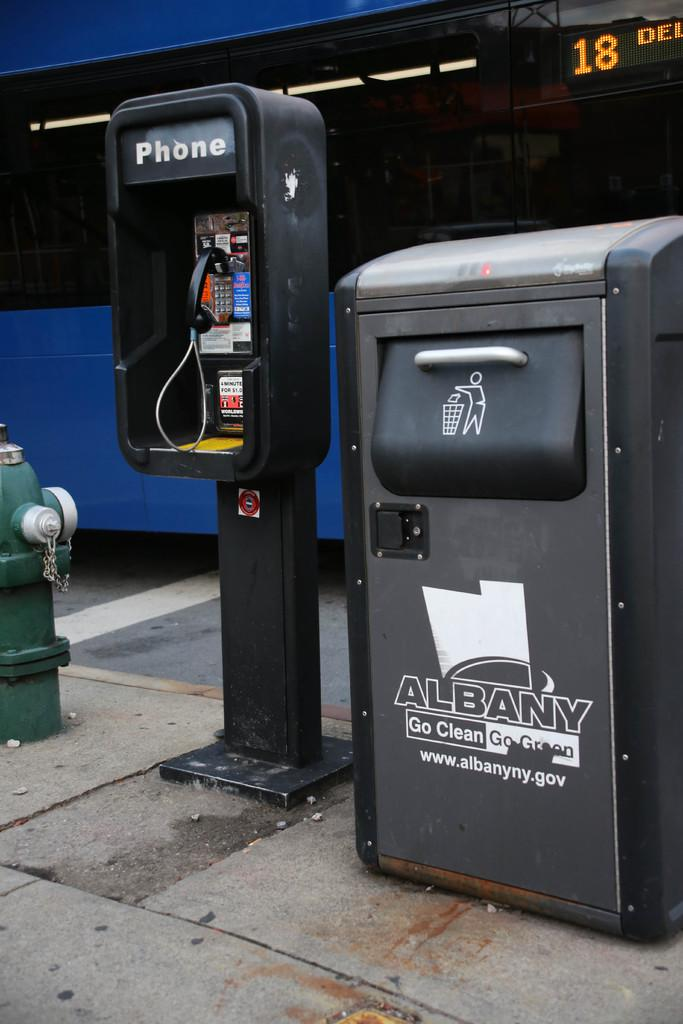Provide a one-sentence caption for the provided image. A city garbage can in Albany is to the right of a pay phone. 